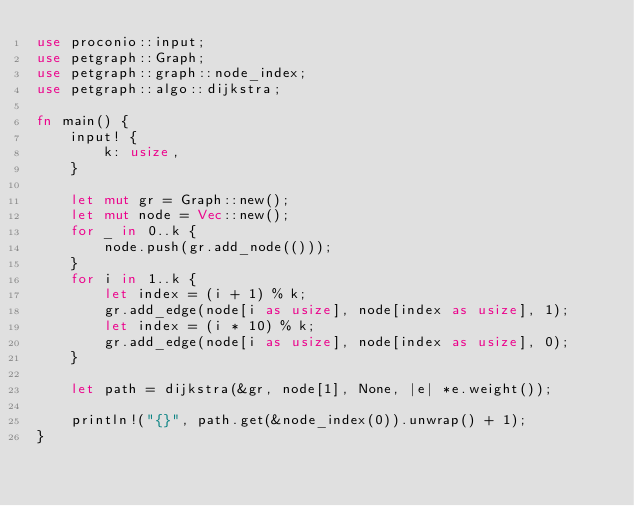Convert code to text. <code><loc_0><loc_0><loc_500><loc_500><_Rust_>use proconio::input;
use petgraph::Graph;
use petgraph::graph::node_index;
use petgraph::algo::dijkstra;
 
fn main() {
    input! {
        k: usize,
    }

    let mut gr = Graph::new();
    let mut node = Vec::new();
    for _ in 0..k {
        node.push(gr.add_node(()));
    }
    for i in 1..k {
        let index = (i + 1) % k;
        gr.add_edge(node[i as usize], node[index as usize], 1);
        let index = (i * 10) % k;
        gr.add_edge(node[i as usize], node[index as usize], 0);
    }

    let path = dijkstra(&gr, node[1], None, |e| *e.weight());

    println!("{}", path.get(&node_index(0)).unwrap() + 1);
}
</code> 